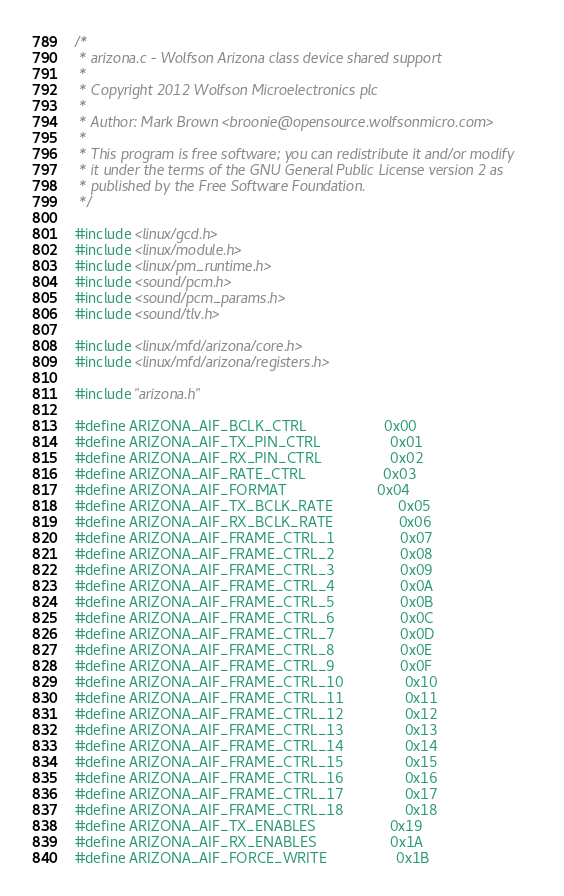Convert code to text. <code><loc_0><loc_0><loc_500><loc_500><_C_>/*
 * arizona.c - Wolfson Arizona class device shared support
 *
 * Copyright 2012 Wolfson Microelectronics plc
 *
 * Author: Mark Brown <broonie@opensource.wolfsonmicro.com>
 *
 * This program is free software; you can redistribute it and/or modify
 * it under the terms of the GNU General Public License version 2 as
 * published by the Free Software Foundation.
 */

#include <linux/gcd.h>
#include <linux/module.h>
#include <linux/pm_runtime.h>
#include <sound/pcm.h>
#include <sound/pcm_params.h>
#include <sound/tlv.h>

#include <linux/mfd/arizona/core.h>
#include <linux/mfd/arizona/registers.h>

#include "arizona.h"

#define ARIZONA_AIF_BCLK_CTRL                   0x00
#define ARIZONA_AIF_TX_PIN_CTRL                 0x01
#define ARIZONA_AIF_RX_PIN_CTRL                 0x02
#define ARIZONA_AIF_RATE_CTRL                   0x03
#define ARIZONA_AIF_FORMAT                      0x04
#define ARIZONA_AIF_TX_BCLK_RATE                0x05
#define ARIZONA_AIF_RX_BCLK_RATE                0x06
#define ARIZONA_AIF_FRAME_CTRL_1                0x07
#define ARIZONA_AIF_FRAME_CTRL_2                0x08
#define ARIZONA_AIF_FRAME_CTRL_3                0x09
#define ARIZONA_AIF_FRAME_CTRL_4                0x0A
#define ARIZONA_AIF_FRAME_CTRL_5                0x0B
#define ARIZONA_AIF_FRAME_CTRL_6                0x0C
#define ARIZONA_AIF_FRAME_CTRL_7                0x0D
#define ARIZONA_AIF_FRAME_CTRL_8                0x0E
#define ARIZONA_AIF_FRAME_CTRL_9                0x0F
#define ARIZONA_AIF_FRAME_CTRL_10               0x10
#define ARIZONA_AIF_FRAME_CTRL_11               0x11
#define ARIZONA_AIF_FRAME_CTRL_12               0x12
#define ARIZONA_AIF_FRAME_CTRL_13               0x13
#define ARIZONA_AIF_FRAME_CTRL_14               0x14
#define ARIZONA_AIF_FRAME_CTRL_15               0x15
#define ARIZONA_AIF_FRAME_CTRL_16               0x16
#define ARIZONA_AIF_FRAME_CTRL_17               0x17
#define ARIZONA_AIF_FRAME_CTRL_18               0x18
#define ARIZONA_AIF_TX_ENABLES                  0x19
#define ARIZONA_AIF_RX_ENABLES                  0x1A
#define ARIZONA_AIF_FORCE_WRITE                 0x1B
</code> 